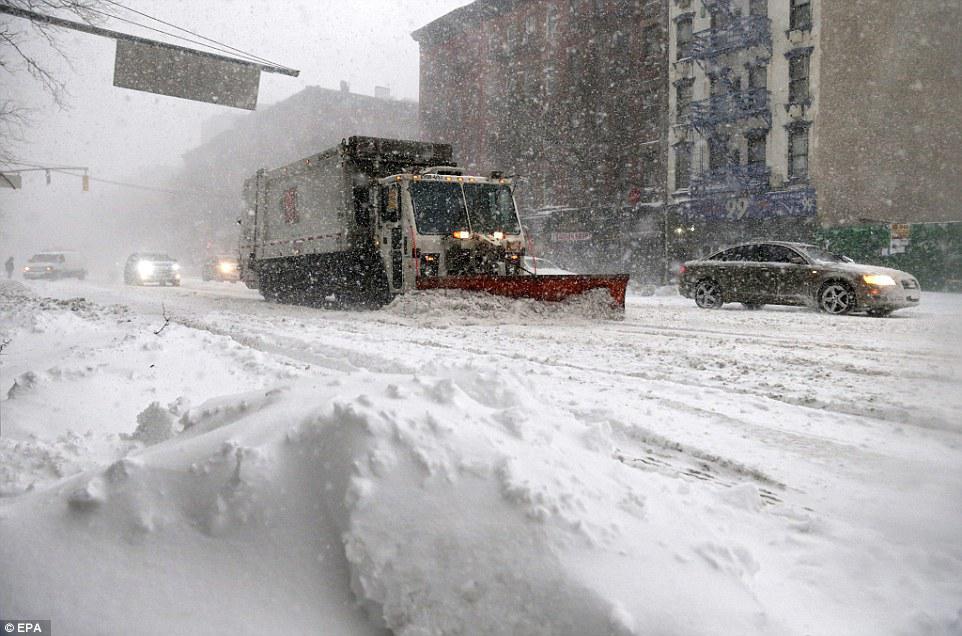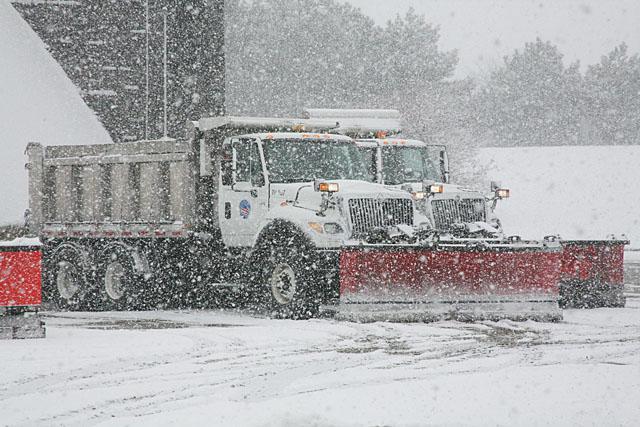The first image is the image on the left, the second image is the image on the right. Considering the images on both sides, is "It is actively snowing in at least one of the images." valid? Answer yes or no. Yes. The first image is the image on the left, the second image is the image on the right. Analyze the images presented: Is the assertion "Each image shows a front-facing truck pushing a snowplow on a snow-covered surface." valid? Answer yes or no. Yes. 